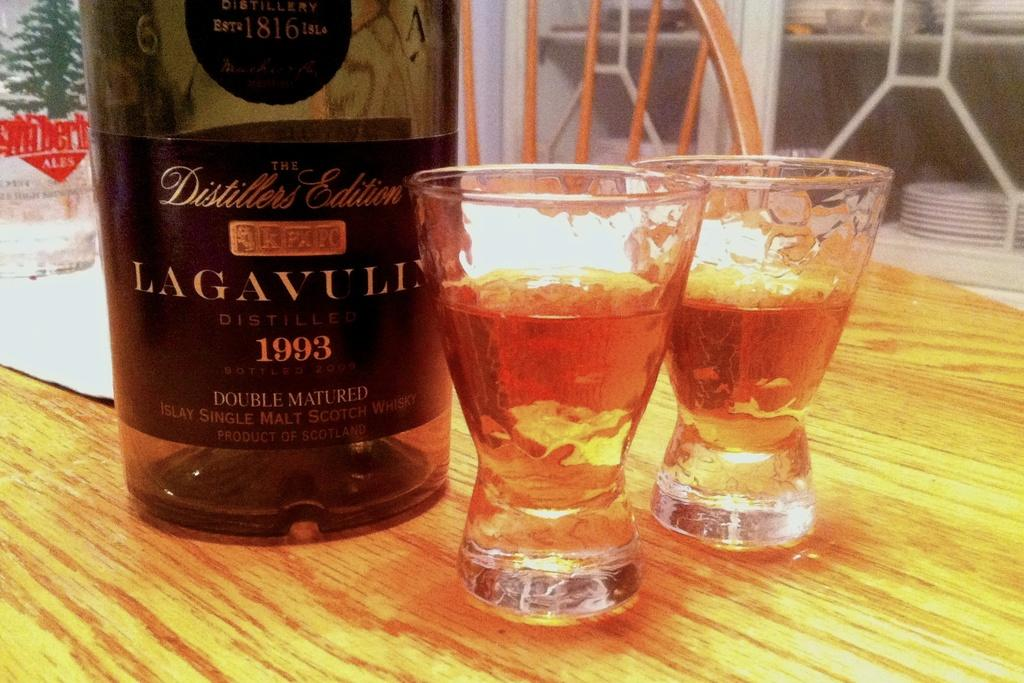<image>
Create a compact narrative representing the image presented. Wooden table with glasses and a Large bottle of French Wine from the year 1993. 